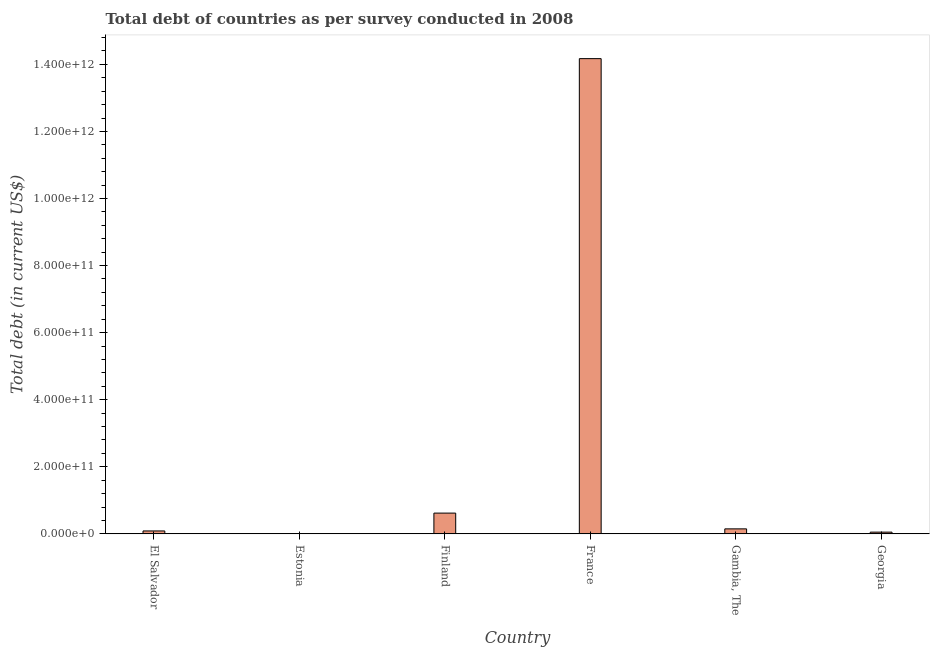Does the graph contain grids?
Ensure brevity in your answer.  No. What is the title of the graph?
Ensure brevity in your answer.  Total debt of countries as per survey conducted in 2008. What is the label or title of the X-axis?
Give a very brief answer. Country. What is the label or title of the Y-axis?
Offer a very short reply. Total debt (in current US$). What is the total debt in Georgia?
Keep it short and to the point. 5.15e+09. Across all countries, what is the maximum total debt?
Provide a succinct answer. 1.42e+12. Across all countries, what is the minimum total debt?
Offer a terse response. 9.20e+08. In which country was the total debt minimum?
Give a very brief answer. Estonia. What is the sum of the total debt?
Ensure brevity in your answer.  1.51e+12. What is the difference between the total debt in Estonia and Georgia?
Your answer should be very brief. -4.23e+09. What is the average total debt per country?
Ensure brevity in your answer.  2.51e+11. What is the median total debt?
Give a very brief answer. 1.18e+1. In how many countries, is the total debt greater than 80000000000 US$?
Provide a succinct answer. 1. What is the ratio of the total debt in France to that in Gambia, The?
Your answer should be compact. 95.2. What is the difference between the highest and the second highest total debt?
Offer a terse response. 1.36e+12. Is the sum of the total debt in El Salvador and Estonia greater than the maximum total debt across all countries?
Offer a very short reply. No. What is the difference between the highest and the lowest total debt?
Your answer should be very brief. 1.42e+12. Are all the bars in the graph horizontal?
Your answer should be very brief. No. How many countries are there in the graph?
Your response must be concise. 6. What is the difference between two consecutive major ticks on the Y-axis?
Offer a very short reply. 2.00e+11. What is the Total debt (in current US$) of El Salvador?
Provide a succinct answer. 8.71e+09. What is the Total debt (in current US$) of Estonia?
Provide a short and direct response. 9.20e+08. What is the Total debt (in current US$) in Finland?
Provide a succinct answer. 6.19e+1. What is the Total debt (in current US$) in France?
Keep it short and to the point. 1.42e+12. What is the Total debt (in current US$) of Gambia, The?
Your answer should be very brief. 1.49e+1. What is the Total debt (in current US$) in Georgia?
Provide a short and direct response. 5.15e+09. What is the difference between the Total debt (in current US$) in El Salvador and Estonia?
Give a very brief answer. 7.79e+09. What is the difference between the Total debt (in current US$) in El Salvador and Finland?
Keep it short and to the point. -5.32e+1. What is the difference between the Total debt (in current US$) in El Salvador and France?
Make the answer very short. -1.41e+12. What is the difference between the Total debt (in current US$) in El Salvador and Gambia, The?
Keep it short and to the point. -6.17e+09. What is the difference between the Total debt (in current US$) in El Salvador and Georgia?
Your response must be concise. 3.56e+09. What is the difference between the Total debt (in current US$) in Estonia and Finland?
Your answer should be compact. -6.10e+1. What is the difference between the Total debt (in current US$) in Estonia and France?
Keep it short and to the point. -1.42e+12. What is the difference between the Total debt (in current US$) in Estonia and Gambia, The?
Your answer should be very brief. -1.40e+1. What is the difference between the Total debt (in current US$) in Estonia and Georgia?
Give a very brief answer. -4.23e+09. What is the difference between the Total debt (in current US$) in Finland and France?
Offer a terse response. -1.36e+12. What is the difference between the Total debt (in current US$) in Finland and Gambia, The?
Provide a short and direct response. 4.70e+1. What is the difference between the Total debt (in current US$) in Finland and Georgia?
Give a very brief answer. 5.68e+1. What is the difference between the Total debt (in current US$) in France and Gambia, The?
Provide a succinct answer. 1.40e+12. What is the difference between the Total debt (in current US$) in France and Georgia?
Your response must be concise. 1.41e+12. What is the difference between the Total debt (in current US$) in Gambia, The and Georgia?
Offer a terse response. 9.73e+09. What is the ratio of the Total debt (in current US$) in El Salvador to that in Estonia?
Provide a succinct answer. 9.47. What is the ratio of the Total debt (in current US$) in El Salvador to that in Finland?
Provide a succinct answer. 0.14. What is the ratio of the Total debt (in current US$) in El Salvador to that in France?
Your answer should be compact. 0.01. What is the ratio of the Total debt (in current US$) in El Salvador to that in Gambia, The?
Provide a short and direct response. 0.58. What is the ratio of the Total debt (in current US$) in El Salvador to that in Georgia?
Give a very brief answer. 1.69. What is the ratio of the Total debt (in current US$) in Estonia to that in Finland?
Ensure brevity in your answer.  0.01. What is the ratio of the Total debt (in current US$) in Estonia to that in Gambia, The?
Make the answer very short. 0.06. What is the ratio of the Total debt (in current US$) in Estonia to that in Georgia?
Make the answer very short. 0.18. What is the ratio of the Total debt (in current US$) in Finland to that in France?
Make the answer very short. 0.04. What is the ratio of the Total debt (in current US$) in Finland to that in Gambia, The?
Provide a short and direct response. 4.16. What is the ratio of the Total debt (in current US$) in Finland to that in Georgia?
Provide a short and direct response. 12.02. What is the ratio of the Total debt (in current US$) in France to that in Gambia, The?
Provide a succinct answer. 95.2. What is the ratio of the Total debt (in current US$) in France to that in Georgia?
Your response must be concise. 274.96. What is the ratio of the Total debt (in current US$) in Gambia, The to that in Georgia?
Keep it short and to the point. 2.89. 